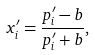Convert formula to latex. <formula><loc_0><loc_0><loc_500><loc_500>x _ { i } ^ { \prime } = { \frac { p _ { i } ^ { \prime } - b } { p _ { i } ^ { \prime } + b } } ,</formula> 